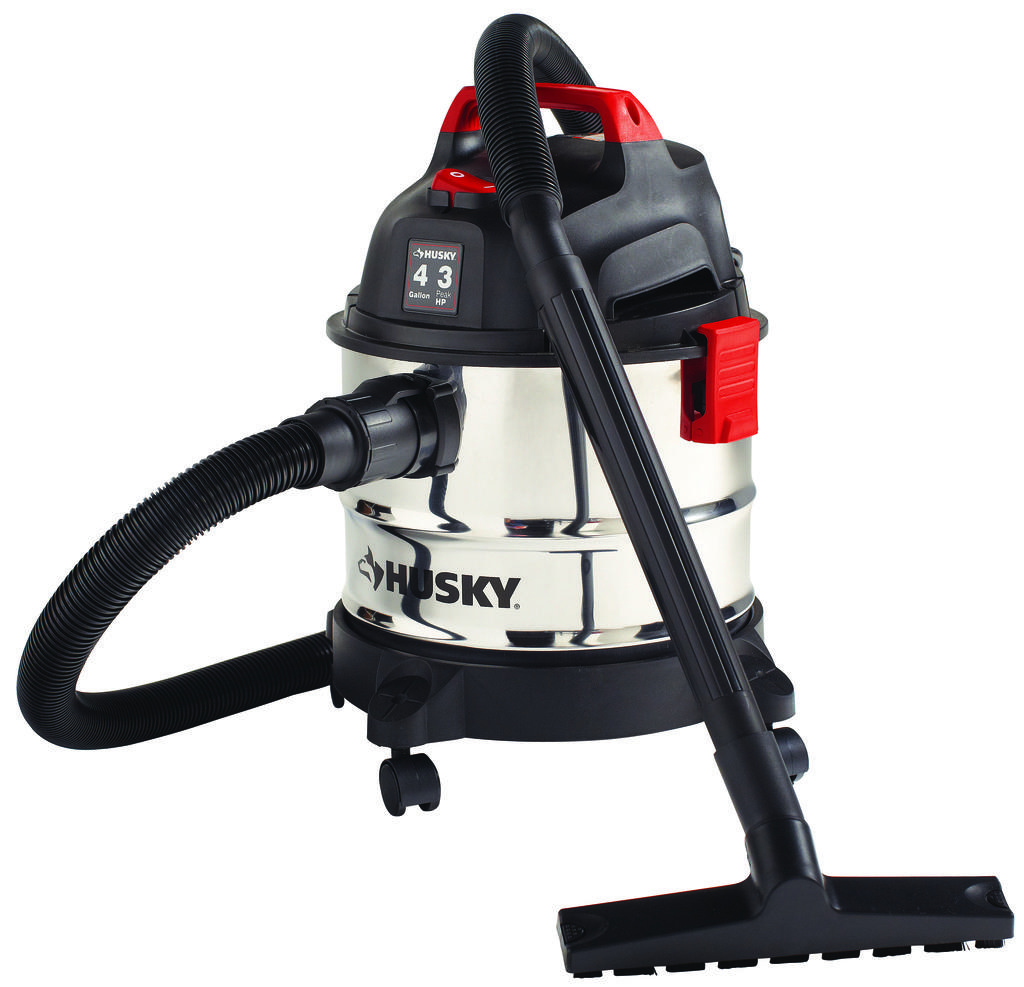What type of appliance is visible in the image? There is a vacuum cleaner in the image. What might the vacuum cleaner be used for? The vacuum cleaner is likely used for cleaning floors or carpets. Can you describe the appearance of the vacuum cleaner? The vacuum cleaner appears to be a standard household model. What type of drug is the grandmother cooking on the stove in the image? There is no grandmother or stove present in the image; it only features a vacuum cleaner. 